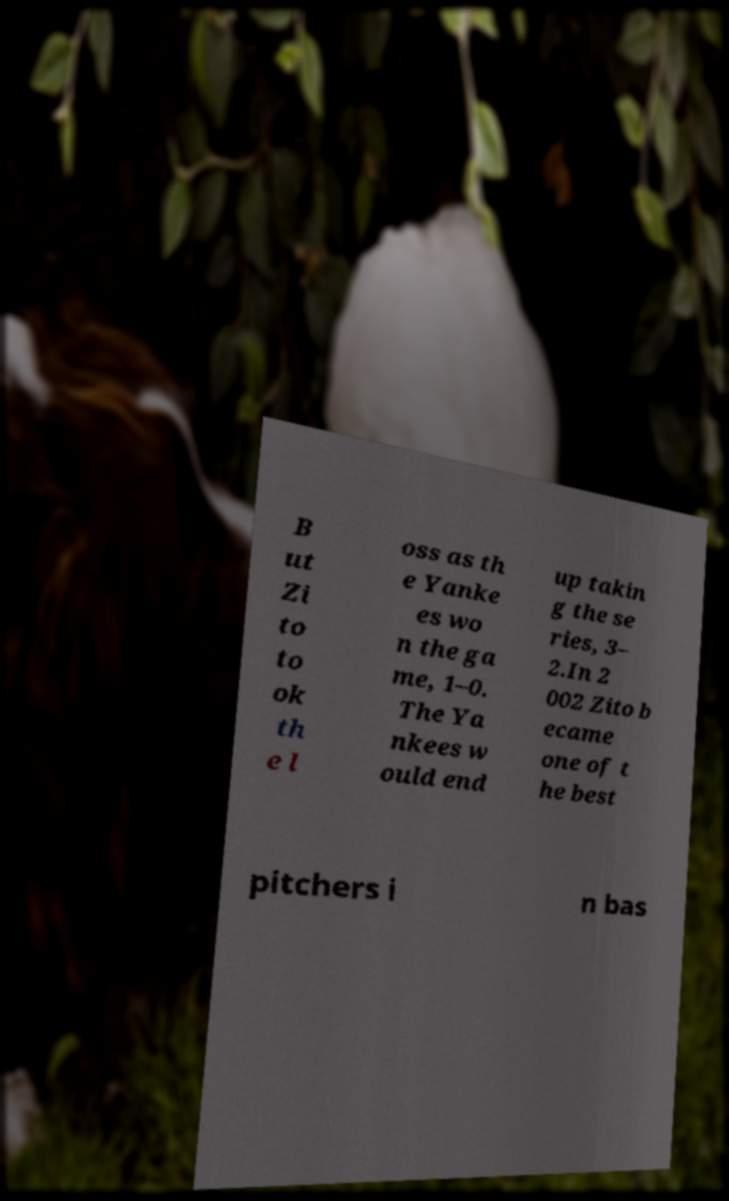Please identify and transcribe the text found in this image. B ut Zi to to ok th e l oss as th e Yanke es wo n the ga me, 1–0. The Ya nkees w ould end up takin g the se ries, 3– 2.In 2 002 Zito b ecame one of t he best pitchers i n bas 